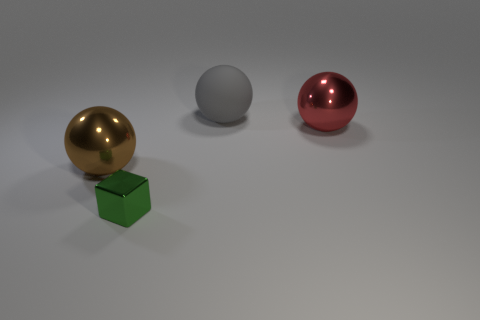Are there more matte things than balls?
Your answer should be very brief. No. What is the color of the large shiny object that is right of the big thing in front of the large shiny ball that is behind the brown metallic ball?
Your answer should be compact. Red. There is a metal thing that is behind the brown object; is it the same shape as the rubber object?
Provide a short and direct response. Yes. What color is the other shiny sphere that is the same size as the brown metallic sphere?
Make the answer very short. Red. What number of green shiny things are there?
Offer a terse response. 1. Does the large thing that is on the right side of the gray matte sphere have the same material as the gray sphere?
Your answer should be very brief. No. What material is the object that is on the left side of the large red metal object and to the right of the tiny metal block?
Your response must be concise. Rubber. There is a large thing that is behind the big metal thing that is on the right side of the tiny metallic cube; what is it made of?
Keep it short and to the point. Rubber. There is a shiny object in front of the large thing in front of the shiny sphere that is on the right side of the gray sphere; what is its size?
Provide a succinct answer. Small. How many small objects are made of the same material as the large red thing?
Offer a very short reply. 1. 